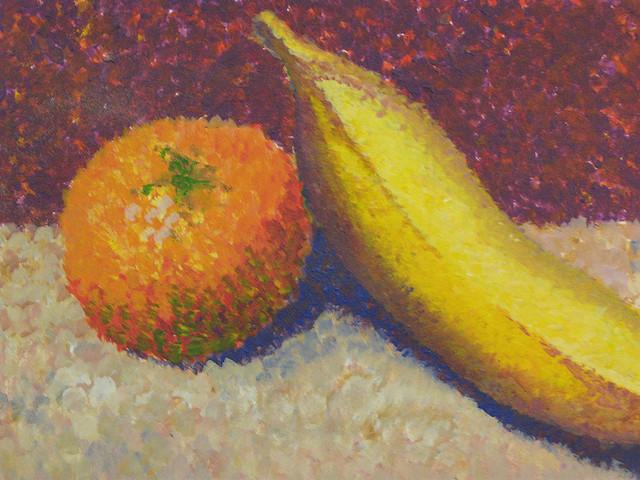How many bananas do you see?
Concise answer only. 1. Is this a photo or a painting?
Concise answer only. Painting. Would you eat this fruit?
Short answer required. No. Is the fruit sliced?
Answer briefly. No. Is the picture in focus?
Concise answer only. No. What is this item?
Be succinct. Painting. 